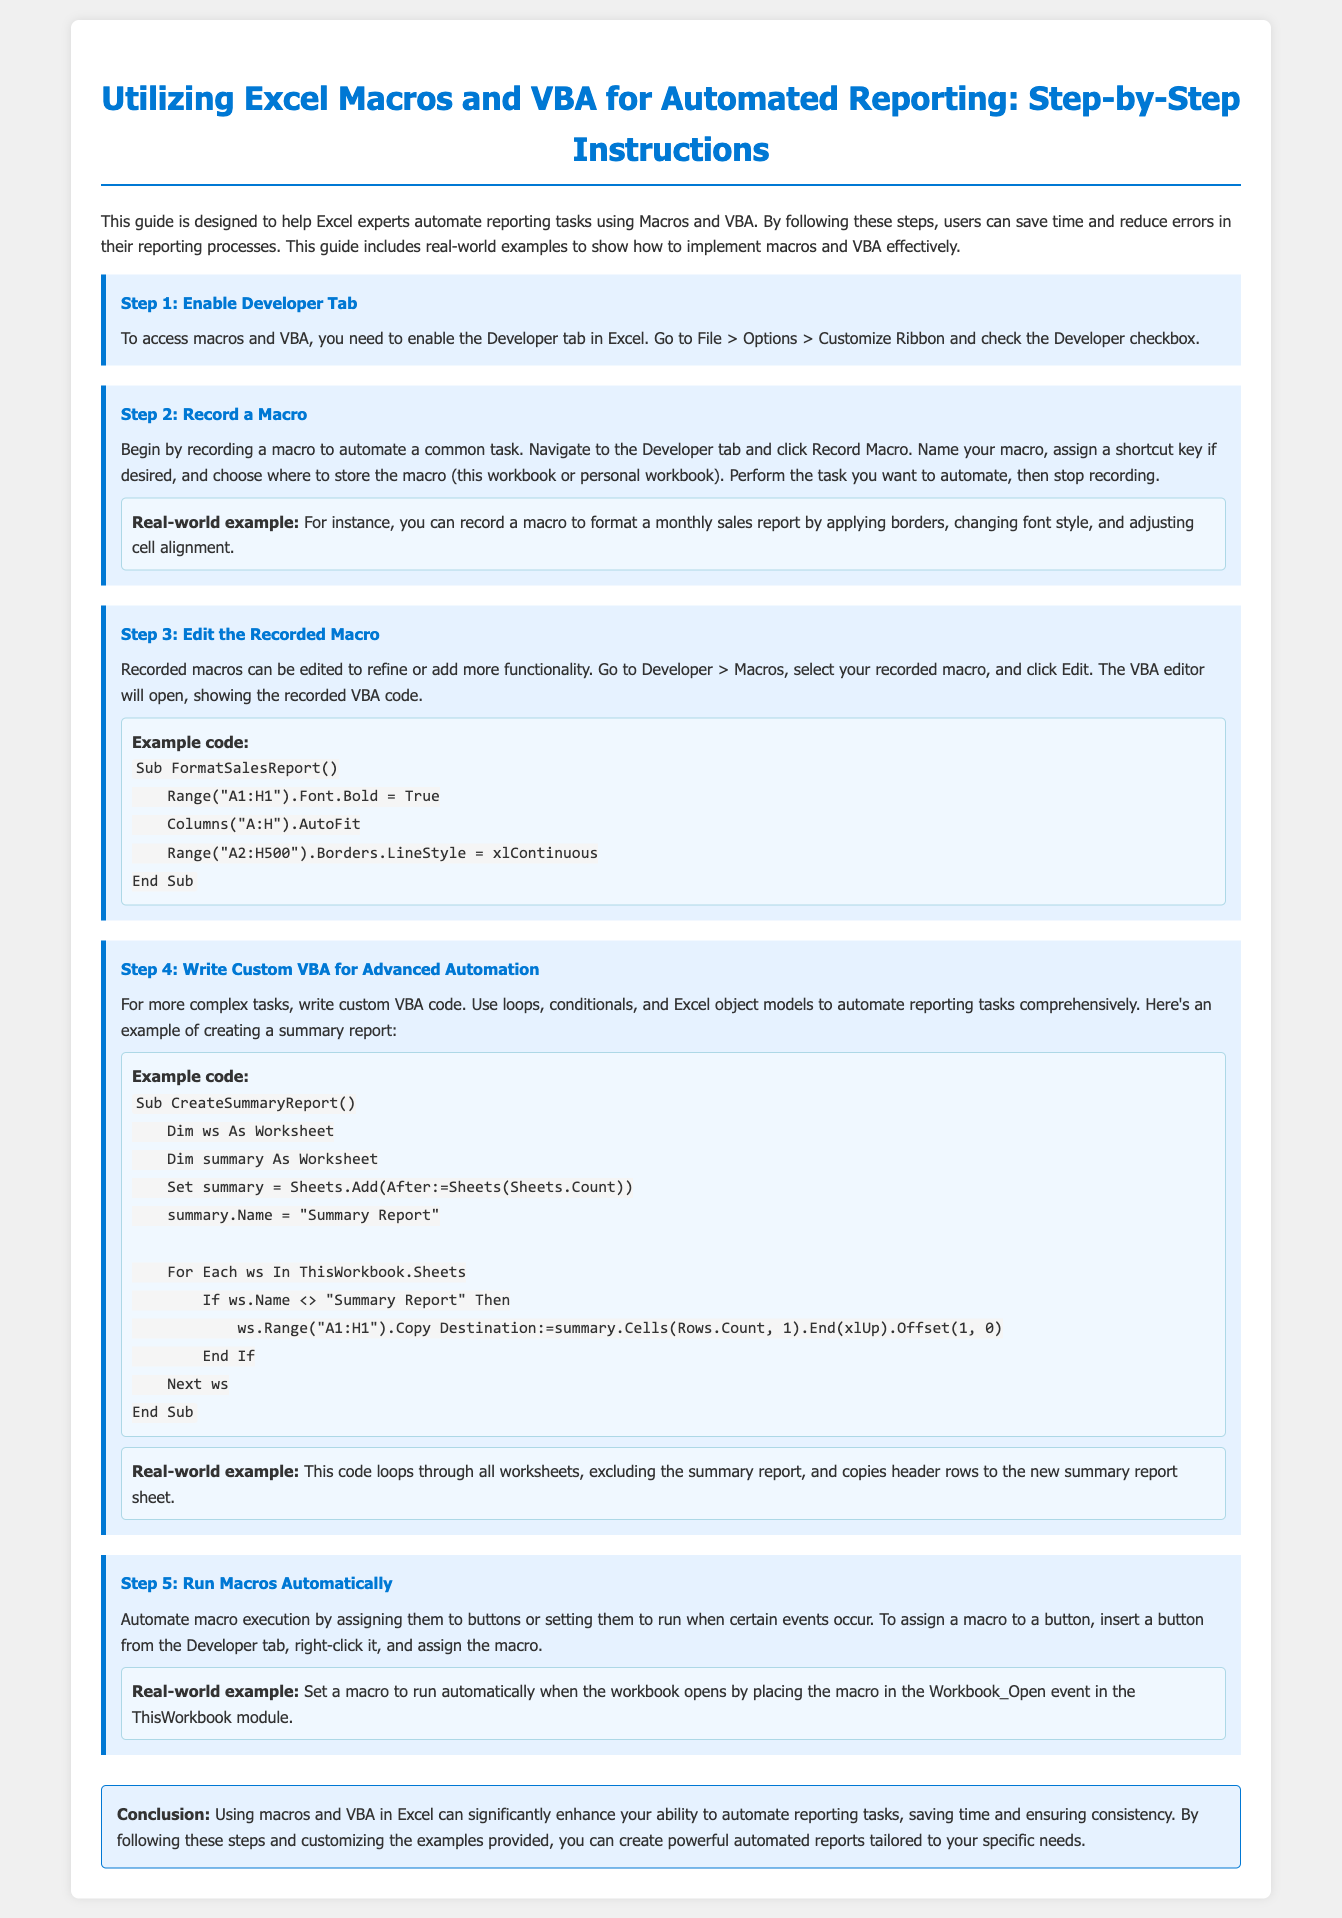What is the title of the guide? The title of the guide is prominently displayed at the top of the document, outlining its focus on automating reporting in Excel.
Answer: Utilizing Excel Macros and VBA for Automated Reporting: Step-by-Step Instructions How many steps are outlined in the document? The document lists a total of five distinct steps for utilizing macros and VBA in Excel.
Answer: 5 What tab needs to be enabled to access macros and VBA? The guide specifies that the Developer tab must be enabled in order to access macros and VBA functionalities.
Answer: Developer What is a real-world example of a macro? The document provides a specific example of formatting a monthly sales report to illustrate the use of a recorded macro.
Answer: Formatting a monthly sales report In which module should a macro be placed to run automatically when the workbook opens? The guide indicates that the macro should be placed in the ThisWorkbook module for automatic execution upon opening the workbook.
Answer: ThisWorkbook What color represents the step background in the guide? The step backgrounds have been designed with a specific color to visually separate them, enhancing readability.
Answer: Light blue What is the primary benefit of using macros and VBA mentioned in the conclusion? The conclusion summarizes the main advantages of using macros and VBA, highlighting the efficiency gained in reporting tasks.
Answer: Save time What should be checked under Customize Ribbon to enable macros? The document instructs users to check a specific box in the Excel options to enable the necessary tab for macros.
Answer: Developer checkbox 